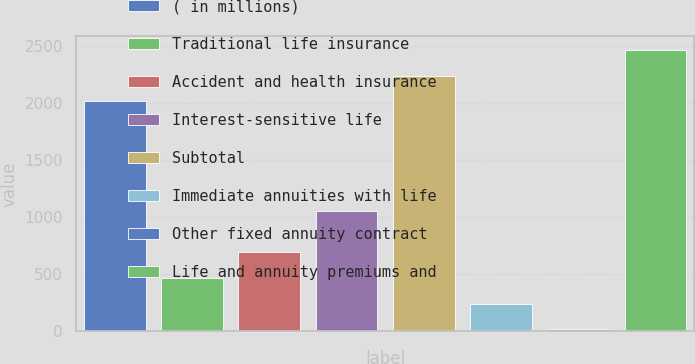Convert chart to OTSL. <chart><loc_0><loc_0><loc_500><loc_500><bar_chart><fcel>( in millions)<fcel>Traditional life insurance<fcel>Accident and health insurance<fcel>Interest-sensitive life<fcel>Subtotal<fcel>Immediate annuities with life<fcel>Other fixed annuity contract<fcel>Life and annuity premiums and<nl><fcel>2012<fcel>470<fcel>692.3<fcel>1055<fcel>2234.3<fcel>240.3<fcel>18<fcel>2456.6<nl></chart> 